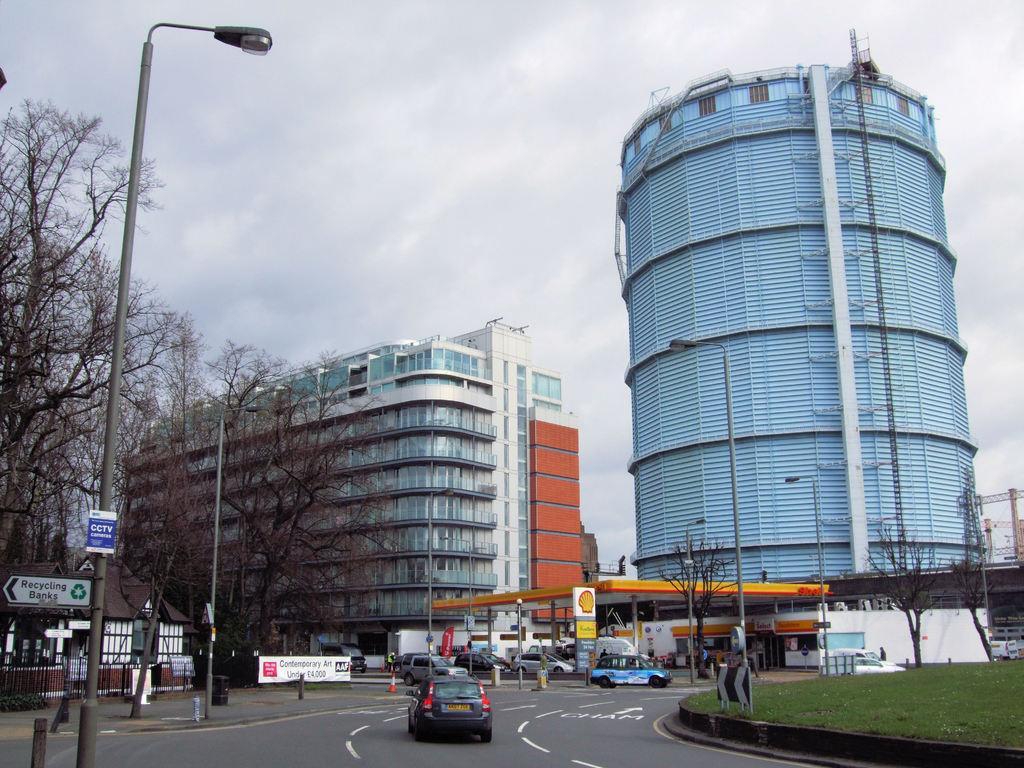Can you describe this image briefly? In this image we can see sky with clouds, buildings, containers, ladder, pipelines, trees, street poles, street lights, motor vehicles on the road and bins. 